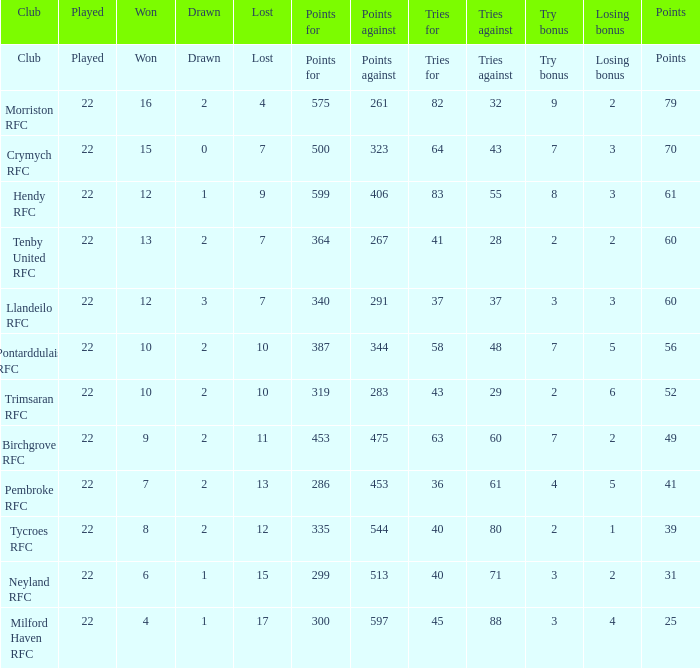What is the club where the losing bonus is 1? Tycroes RFC. 